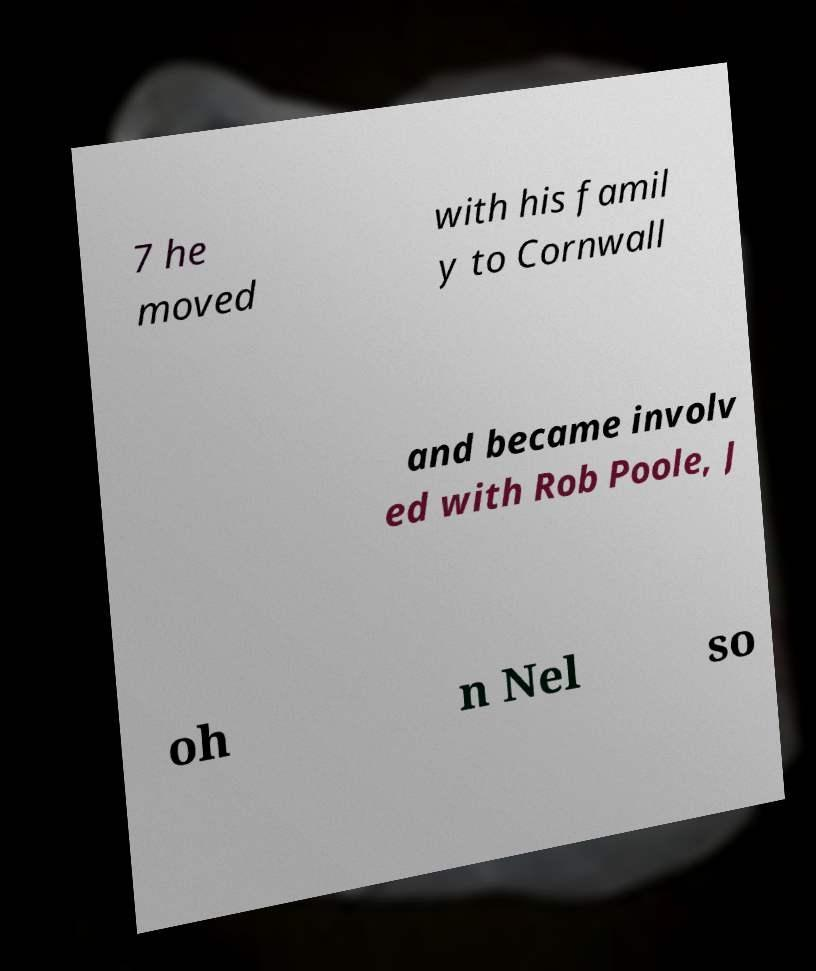What messages or text are displayed in this image? I need them in a readable, typed format. 7 he moved with his famil y to Cornwall and became involv ed with Rob Poole, J oh n Nel so 